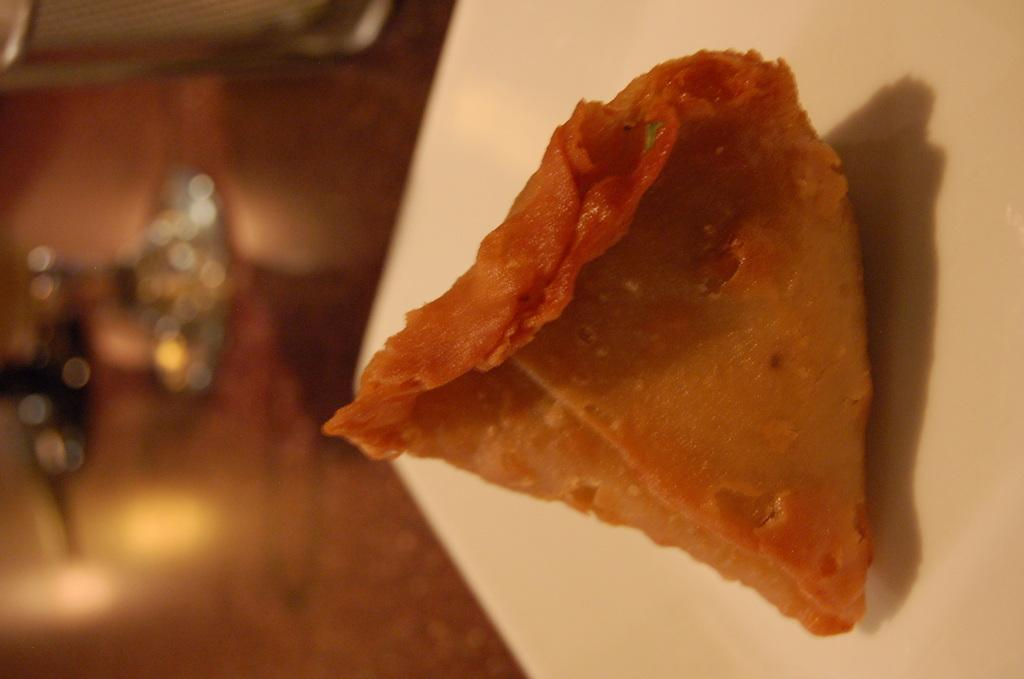What color is the plate in the image? The plate in the image is white. Where is the plate located in the image? The plate is in the center of the image. What food item is on the plate? There is a samosa on the plate. What type of vegetable is the judge holding in the image? There is no judge or vegetable present in the image; it only features a white color plate with a samosa on it. 